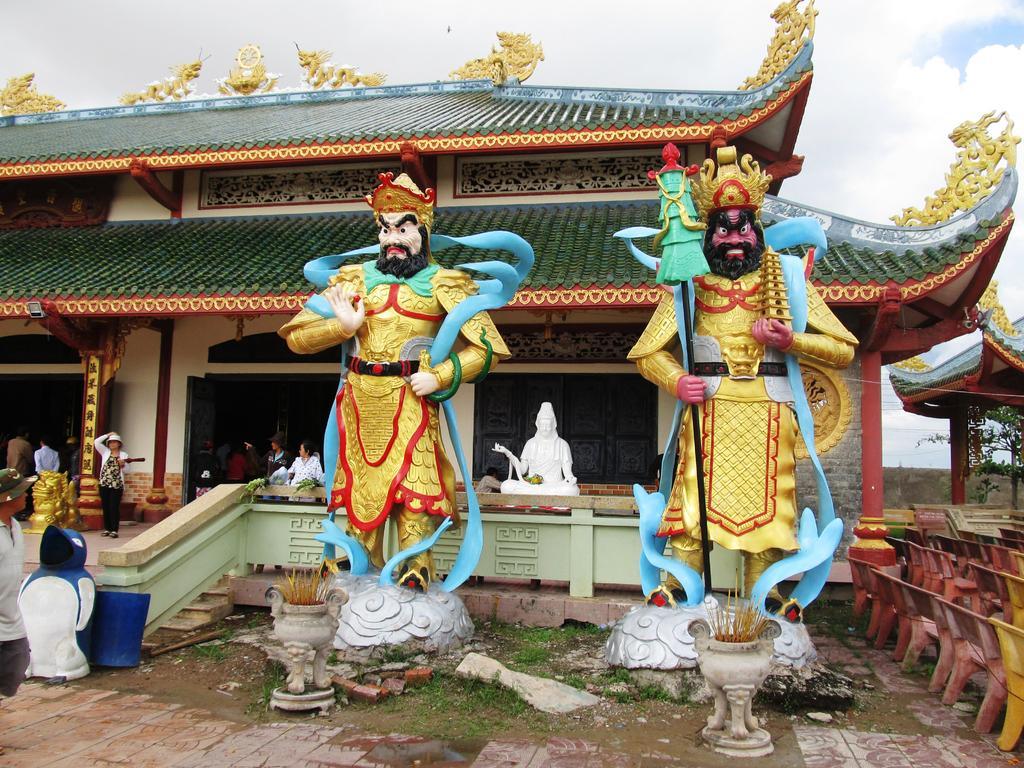Could you give a brief overview of what you see in this image? In this image I can see the ground, few persons standing, few statues, few chairs and a building which is white, brown, green and gold in color. In the background I can see the sky. 